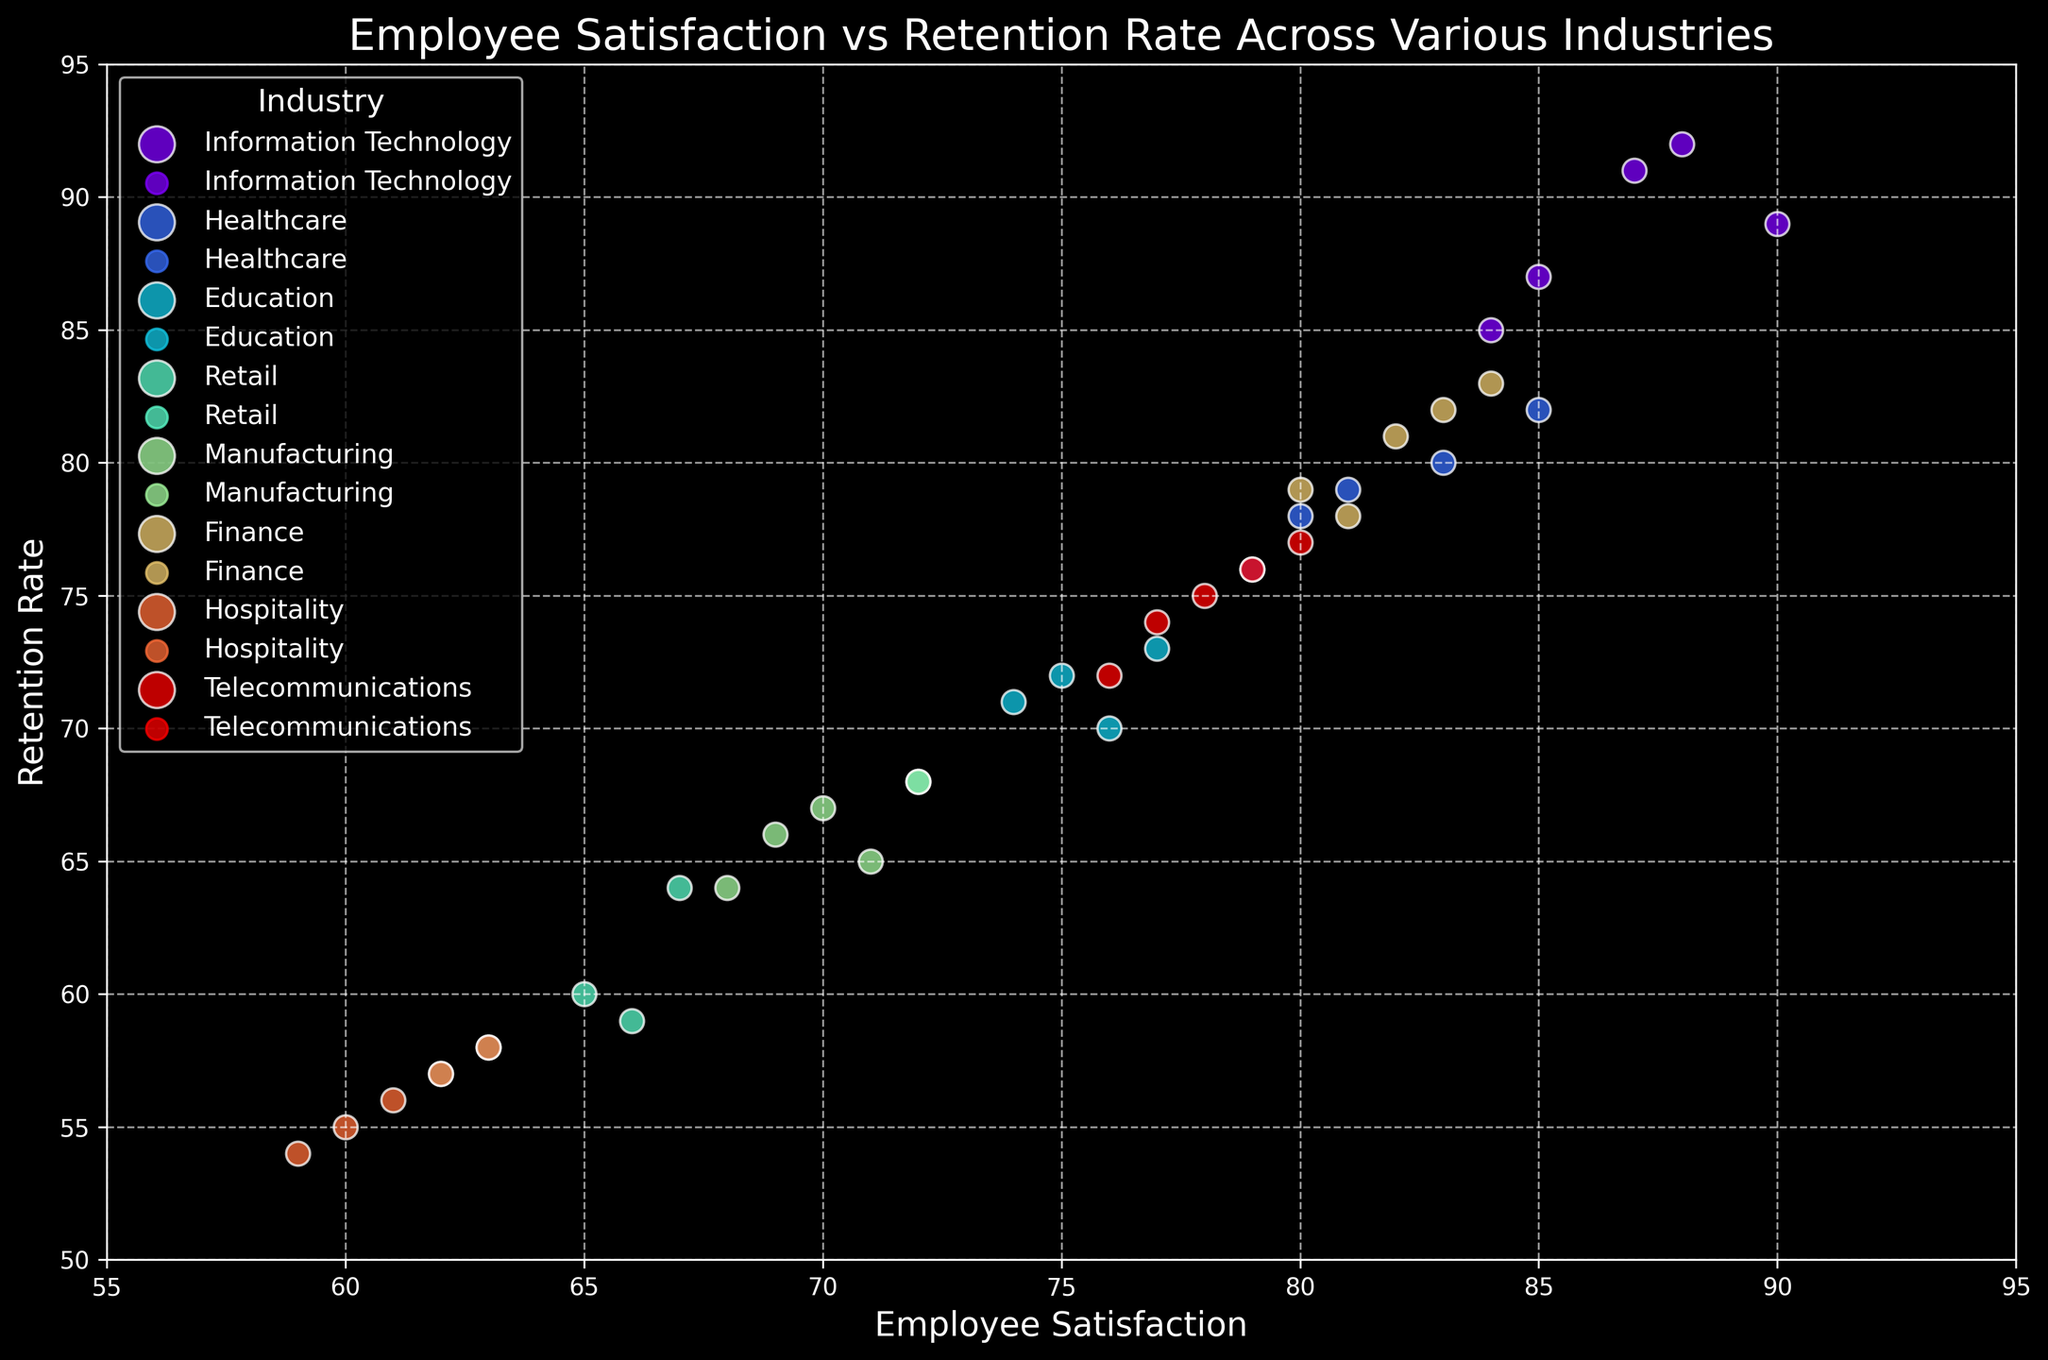What industry has the highest average employee satisfaction? To determine the highest average employee satisfaction, examine the vertical positioning of the clusters along the x-axis. The cluster furthest to the right represents the highest average satisfaction. For Information Technology, the satisfaction values are (88, 85, 90, 87, 84), averaging to (88+85+90+87+84)/5 = 86.8. Healthcare, Education, and other industries can be similarly calculated, confirming Information Technology has the highest average.
Answer: Information Technology Which industry has the lowest retention rate? Observe the clusters and their positioning along the y-axis. The one lowest on the vertical axis indicates the lowest retention rate. Hospitality's retention rates (55, 57, 54, 56, 58), averaging to (55+57+54+56+58)/5 = 56, is the lowest among the industries.
Answer: Hospitality Which two industries have the closest average retention rates? Calculate the average retention rate for each industry and find the two with the smallest difference. For Healthcare: (80+82+78+76+79)/5 = 79. For Finance: (81+79+82+78+83)/5 = 80.6. The difference is 80.6 - 79 = 1.6. This comparison should be repeated for all possible pairs, but Healthcare and Finance are very close.
Answer: Healthcare and Finance Identify an industry with a strong correlation between employee satisfaction and retention rate. Look for clusters where the points follow a closely aligned pattern or a direct visual trend. Information Technology shows a strong positive correlation where higher satisfaction tends to align with higher retention rates, indicating a visual trend.
Answer: Information Technology What is the retention rate range for the Retail industry? Identify the min and max values in the vertical spread of the Retail cluster of points. The retention rates for Retail are (60, 58, 64, 57, 59). The range can be found as max(64) - min(57) = 7.
Answer: 7 Which industry shows the highest variability in employee satisfaction? Assess the width (spread along the x-axis) of each cluster. Greater spread indicates higher variability. Information Technology, with employee satisfaction values (88, 85, 90, 87, 84) showing a range of 90-84=6, reflects notable variability. However, specific comparisons should point to Hospitality as having spread (60, 62, 59, 61, 63) where 63-59=4 being lower, confirming the choice. For comprehensive variability, determine standard deviations if needed.
Answer: Information Technology What is the difference between the highest retention rate in Education and the lowest retention rate in Finance? Identify the highest retention rate in Education—74, 73, 71, 72, 70 (max=74)—and the lowest in Finance—81, 79, 82, 78, 83 (min=78). The difference is 74 - 78 = -4.
Answer: -4 